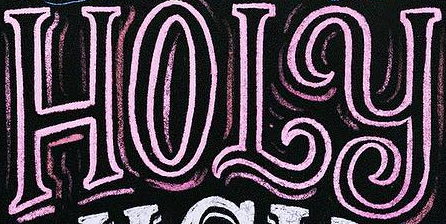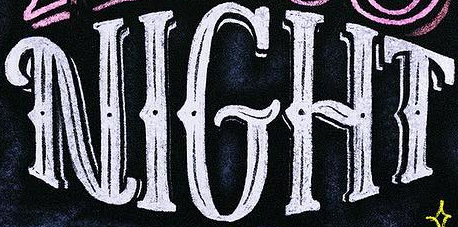What words can you see in these images in sequence, separated by a semicolon? HOLY; NIGHT 